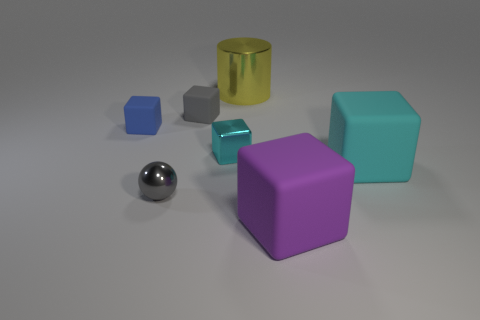What color is the small rubber cube that is in front of the tiny rubber thing right of the metallic object that is left of the small cyan block? blue 